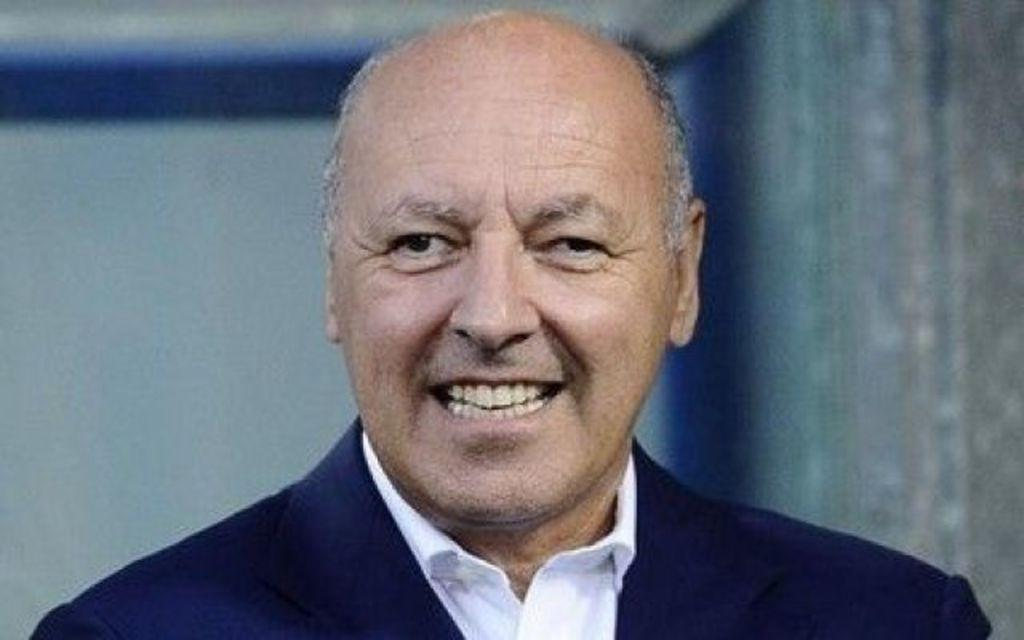Who is the main subject in the image? There is an old man in the image. What is the old man doing in the image? The old man is smiling. What type of clothing is the old man wearing? The old man is wearing a shirt and a suit. Can you describe the background of the image? The background of the image appears blurry. Where is the goat in the image? There is no goat present in the image. What type of faucet can be seen in the image? There is no faucet present in the image. 